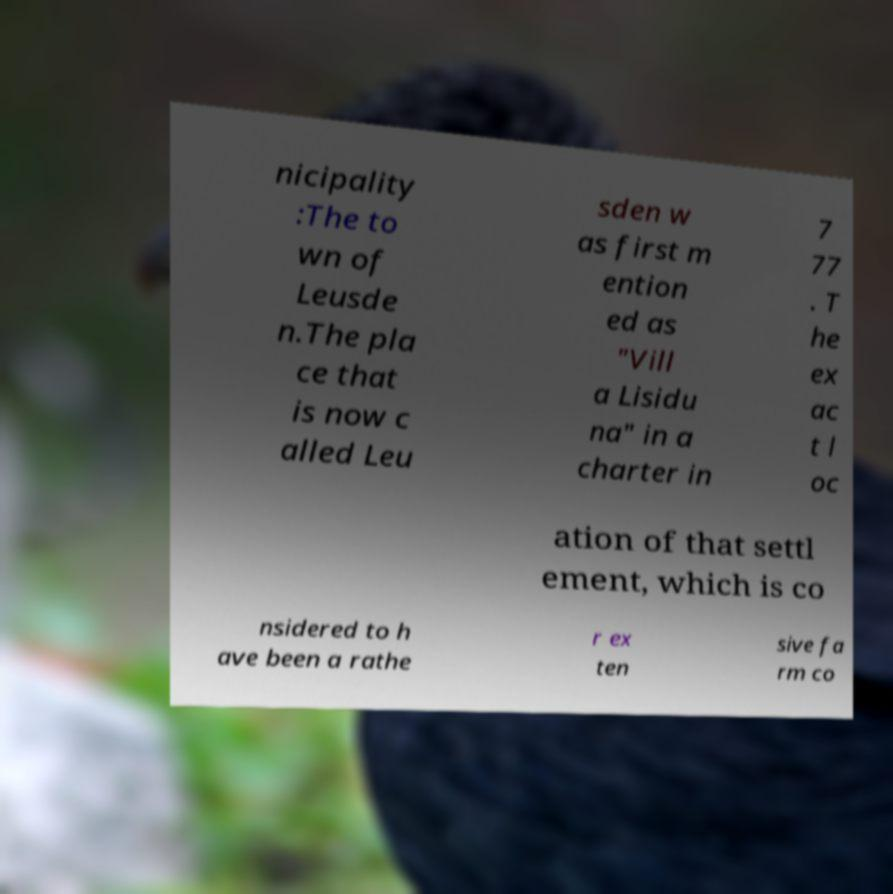I need the written content from this picture converted into text. Can you do that? nicipality :The to wn of Leusde n.The pla ce that is now c alled Leu sden w as first m ention ed as "Vill a Lisidu na" in a charter in 7 77 . T he ex ac t l oc ation of that settl ement, which is co nsidered to h ave been a rathe r ex ten sive fa rm co 